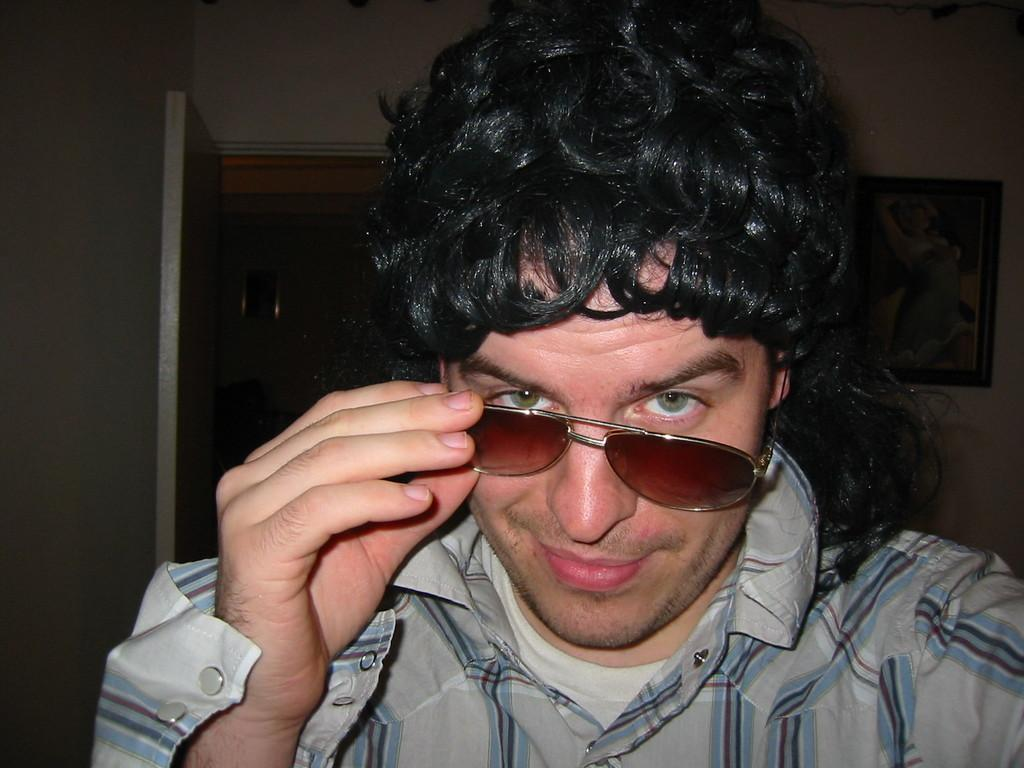What is the main subject of the image? There is a person in the image. What is the person wearing on their upper body? The person is wearing a shirt and a T-shirt. What accessory is the person wearing? The person is wearing glasses. What is the person's facial expression? The person is smiling. What can be seen in the background of the image? The background of the image is dark, and there is a door and a photo frame on the wall. What type of yarn is the person holding in the image? There is no yarn present in the image. What type of quiver is the person wearing on their back in the image? There is no quiver present in the image. 